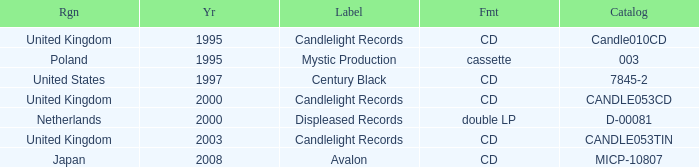What is candlelight records' structure? CD, CD, CD. 